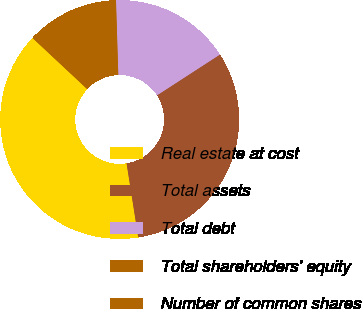<chart> <loc_0><loc_0><loc_500><loc_500><pie_chart><fcel>Real estate at cost<fcel>Total assets<fcel>Total debt<fcel>Total shareholders' equity<fcel>Number of common shares<nl><fcel>39.46%<fcel>31.66%<fcel>16.34%<fcel>12.12%<fcel>0.42%<nl></chart> 